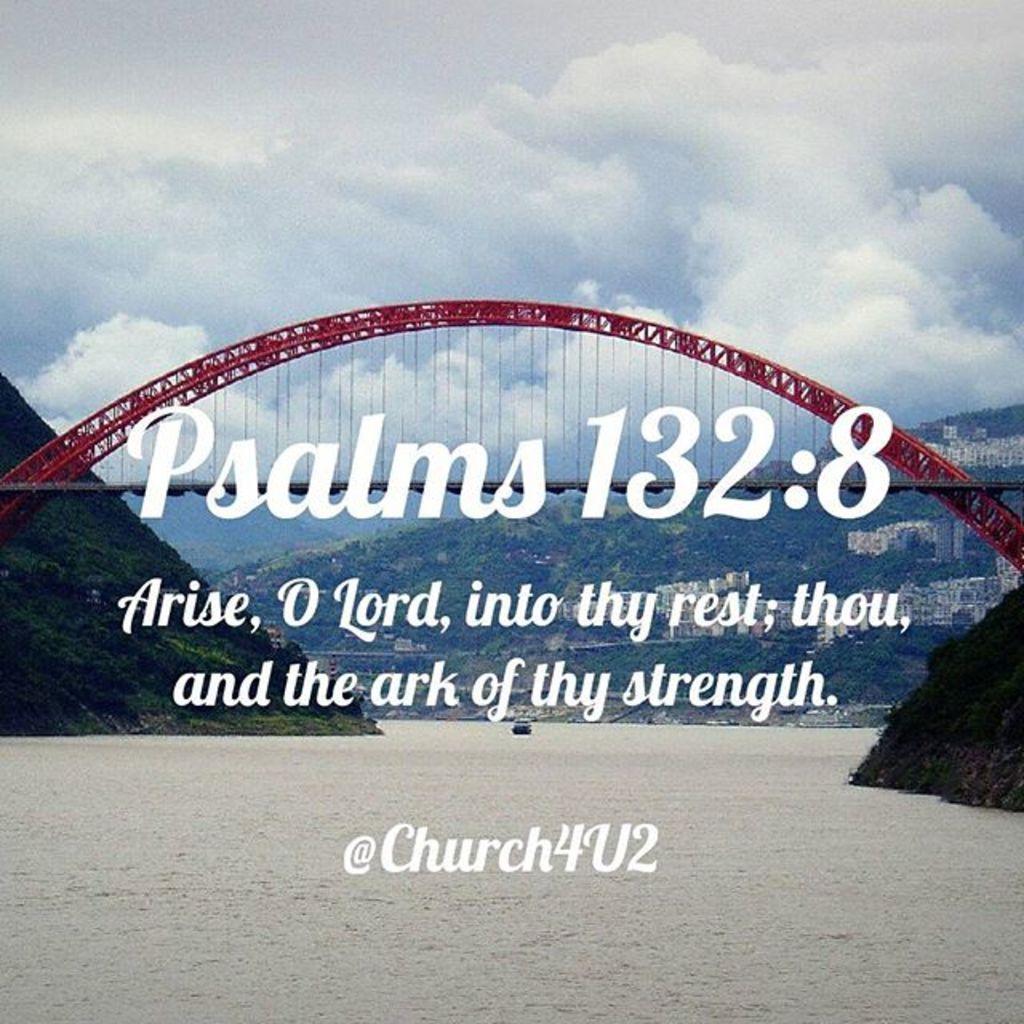Please provide a concise description of this image. In this image there is a bridge. In the background there are trees, hills, buildings. The sky is cloudy. In the image some texts are there. 